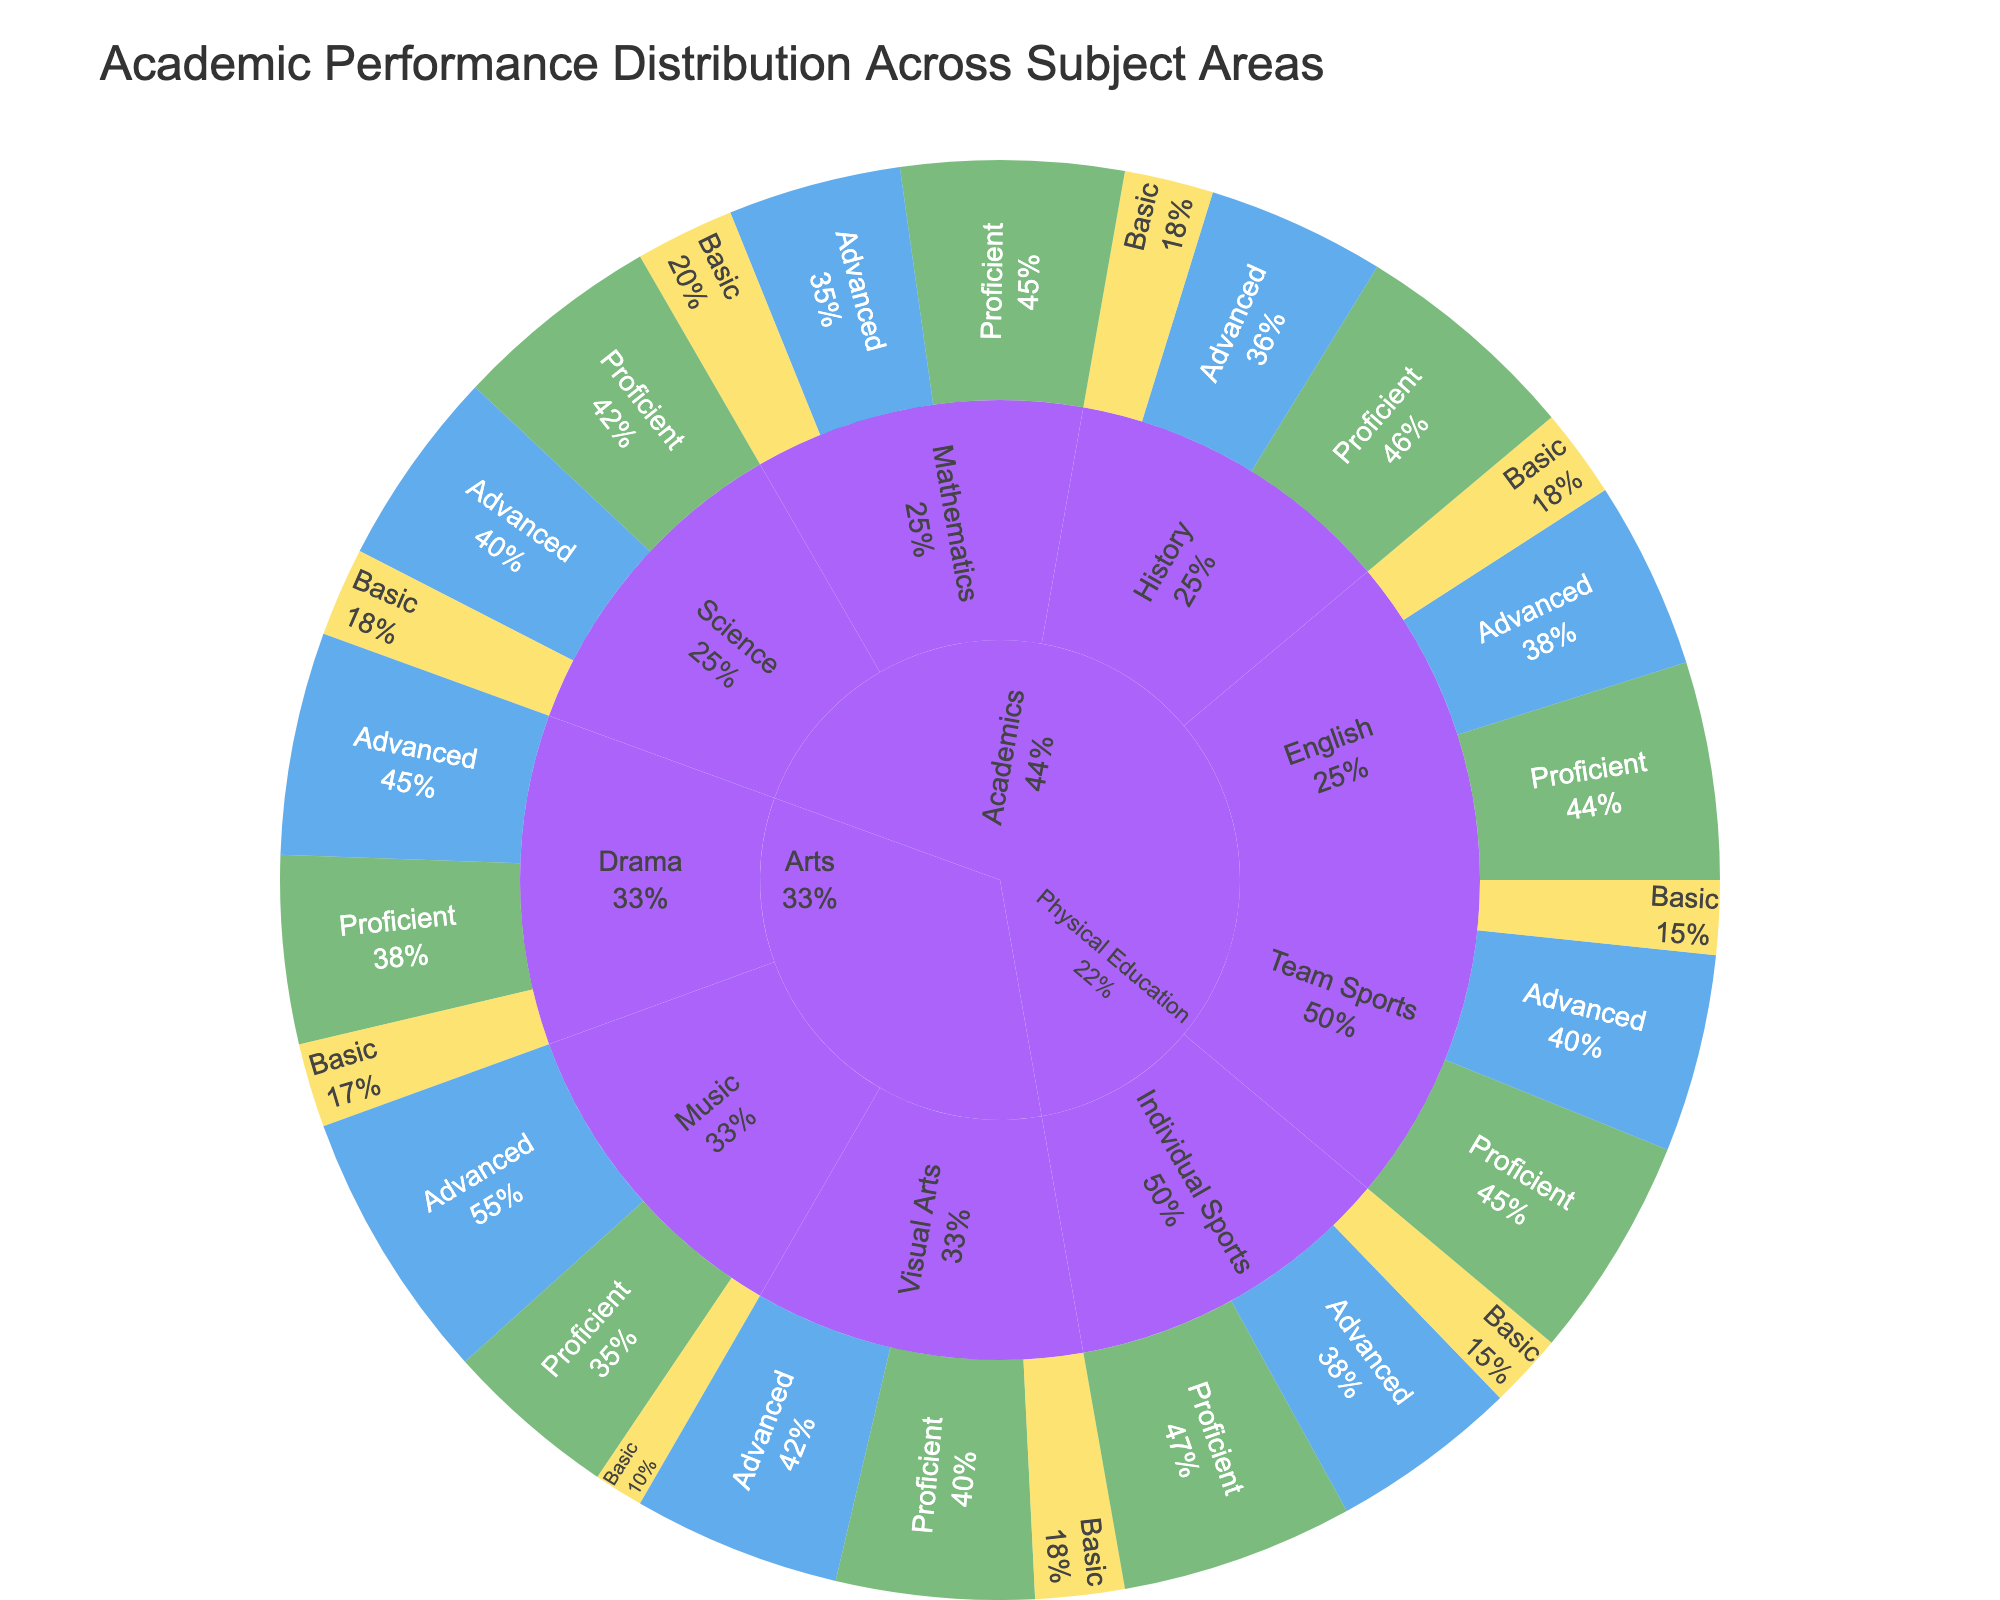What is the title of the figure? The title is at the top of the figure, representing the main subject or description of it.
Answer: Academic Performance Distribution Across Subject Areas How many categories are in the subject 'Arts'? Look at the branches stemming from the root labeled 'Arts', count the different subjects (i.e., branches)
Answer: 3 Which subject shows the highest number of Advanced performances in the 'Academics' category? Review the slices within 'Academics' for each subject's Advanced category, comparing their values.
Answer: Science What percentage of Music students achieved Advanced performance? Observe the proportion of the 'Advanced' section within the 'Music' category. The exact percentage can be seen in the figure when hovering over or reading labels.
Answer: 55% Which category in 'Physical Education' has a higher Basic performance, Team Sports or Individual Sports? Compare the proportion and value of the 'Basic' sections of 'Team Sports' and 'Individual Sports' within 'Physical Education'.
Answer: Same What is the combined value of Proficient performances in Visual Arts and Drama? Identify the values for Proficient in both 'Visual Arts' and 'Drama', and sum them: 40 (Visual Arts) + 38 (Drama) = 78
Answer: 78 What percentage of the total performance in Mathematics is Proficient? Divide the value of Proficient performances in Mathematics by the total performances in Mathematics and multiply by 100: (45 / (35 + 45 + 20)) * 100
Answer: 45% In which category do students have the highest sum of Advanced and Proficient performances in 'Arts'? Sum the Advanced and Proficient values for each Arts category and compare them: Music (55 + 35), Visual Arts (42 + 40), Drama (45 + 38).
Answer: Music Compare the total performances (all levels) in Science and History within the Academics category. Which has a higher total, and by how much? Calculate the total by summing values for all performance levels: Science (40 + 42 + 18) = 100, History (36 + 46 + 18) = 100. Compare the totals.
Answer: Equal, 0 What is the proportion of Advanced performances to the total performances in Physical Education's 'Team Sports'? Divide the Advanced performances in Team Sports by the total performances in Team Sports: 40 / (40 + 45 + 15)
Answer: 40% 